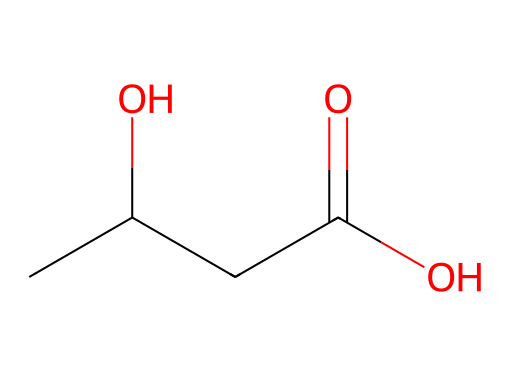What is the molecular formula of beta-hydroxybutyrate? The chemical structure can be broken down to identify the number of each type of atom: 4 carbon atoms (C), 8 hydrogen atoms (H), and 4 oxygen atoms (O). Therefore, we can combine these counts to form the molecular formula C4H8O4.
Answer: C4H8O4 How many hydroxyl (-OH) groups are present in this structure? The structure shows one hydroxyl group, indicated by the -OH attached to one of the carbon atoms. This is confirmed by the notation of the chemical and the visual representation.
Answer: 1 What type of functional groups are present in beta-hydroxybutyrate? The chemical contains a carboxylic acid (-COOH) and a hydroxyl group (-OH). The carbonyl group (C=O) indicates the presence of a ketone too, but since one -OH group is attached, it is classified as a beta-hydroxy acid.
Answer: carboxylic acid, hydroxyl Is beta-hydroxybutyrate an example of a simple or complex ketone? This compound contains a straightforward linear chain and is characterized by having a key functional group attached without further branching or complex substituents, categorizing it as a simple ketone.
Answer: simple How many hydrogen atoms are bonded to the central carbon atom in the ketone structure? Looking at the central carbon atom in the structure, it is connected to one hydrogen atom and the carbonyl oxygen, which determines its valency and bonding configuration; thus, it has only one hydrogen atom attached.
Answer: 1 